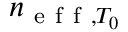<formula> <loc_0><loc_0><loc_500><loc_500>n _ { e f f , T _ { 0 } }</formula> 